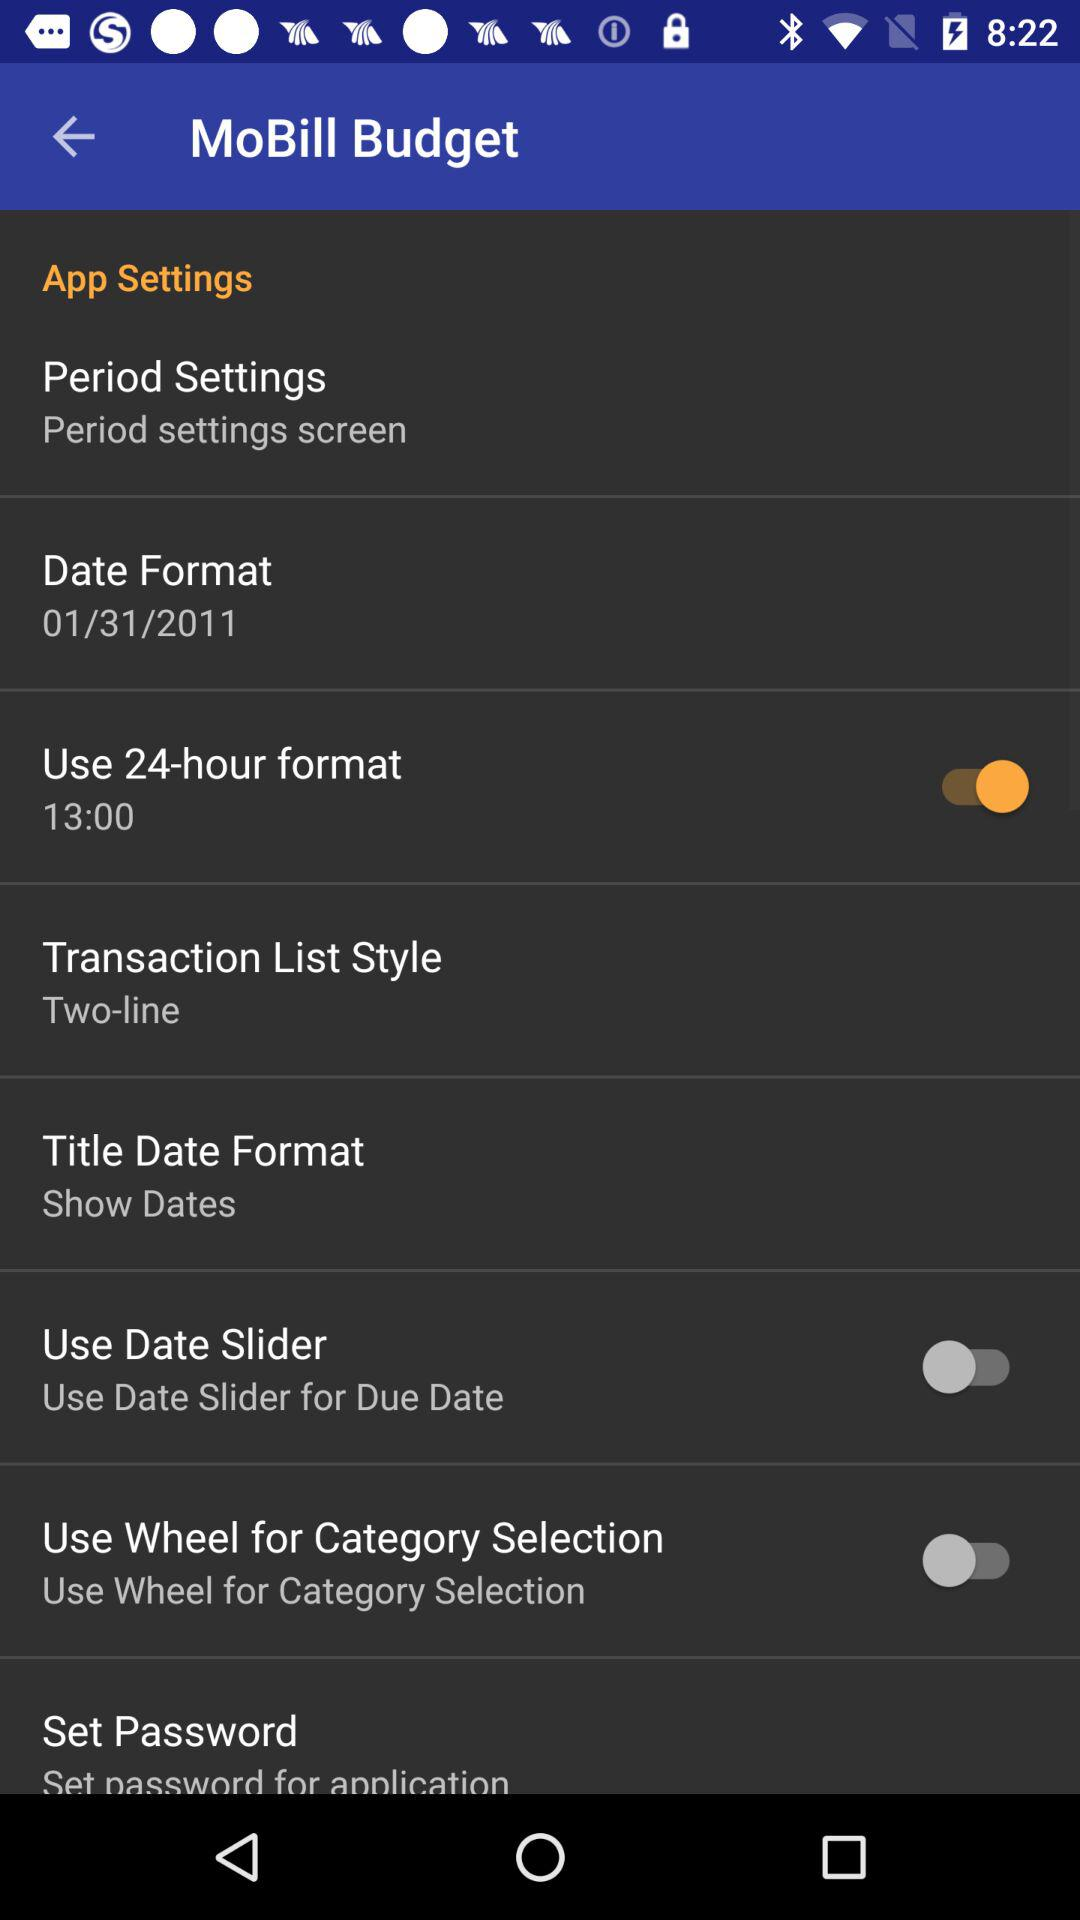What is the status of the "Use Date Slider"? The status of the "Use Date Slider" is "off". 